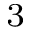Convert formula to latex. <formula><loc_0><loc_0><loc_500><loc_500>^ { 3 }</formula> 